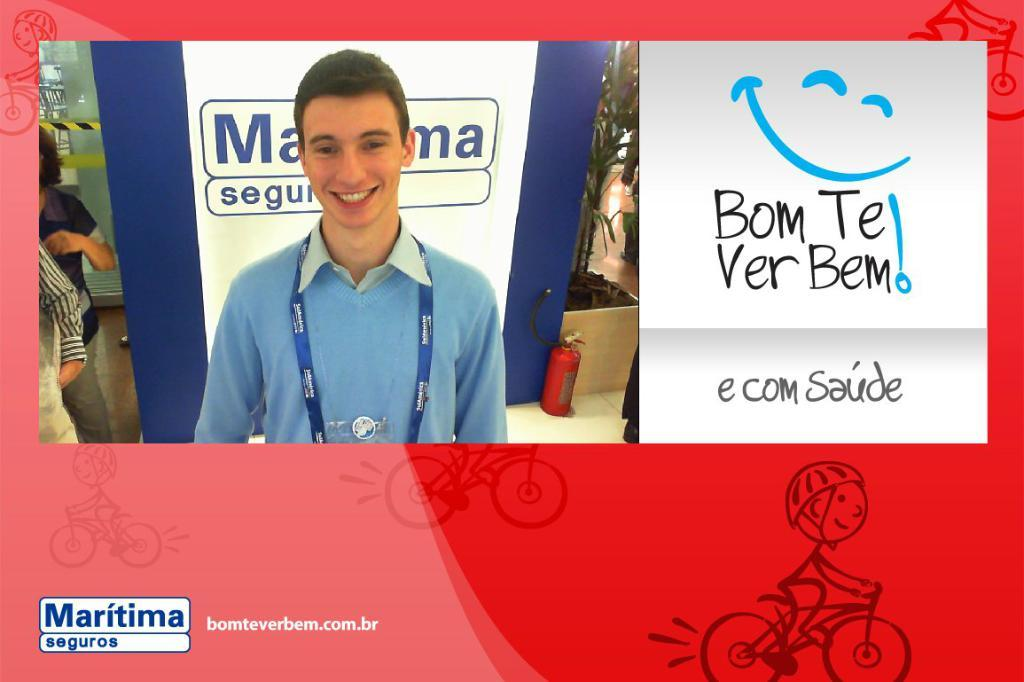<image>
Give a short and clear explanation of the subsequent image. Man standing next to some words which says "bom te ver bem". 